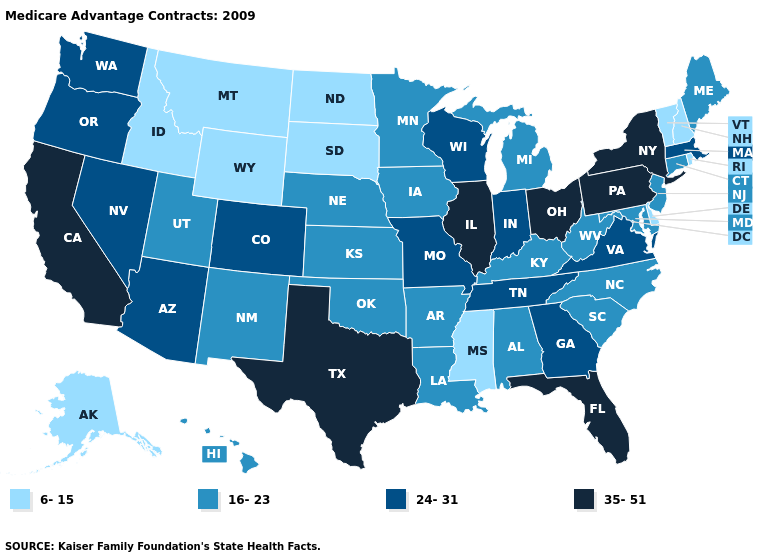What is the value of Illinois?
Write a very short answer. 35-51. Does Georgia have a higher value than West Virginia?
Keep it brief. Yes. Name the states that have a value in the range 16-23?
Quick response, please. Alabama, Arkansas, Connecticut, Hawaii, Iowa, Kansas, Kentucky, Louisiana, Maryland, Maine, Michigan, Minnesota, North Carolina, Nebraska, New Jersey, New Mexico, Oklahoma, South Carolina, Utah, West Virginia. What is the value of Florida?
Write a very short answer. 35-51. Name the states that have a value in the range 24-31?
Be succinct. Arizona, Colorado, Georgia, Indiana, Massachusetts, Missouri, Nevada, Oregon, Tennessee, Virginia, Washington, Wisconsin. Does Idaho have the highest value in the West?
Short answer required. No. What is the value of Wyoming?
Concise answer only. 6-15. What is the highest value in the South ?
Write a very short answer. 35-51. Does Tennessee have the same value as Illinois?
Quick response, please. No. Among the states that border New Jersey , does Pennsylvania have the highest value?
Give a very brief answer. Yes. Among the states that border Louisiana , which have the lowest value?
Write a very short answer. Mississippi. Which states have the highest value in the USA?
Be succinct. California, Florida, Illinois, New York, Ohio, Pennsylvania, Texas. What is the value of West Virginia?
Write a very short answer. 16-23. Name the states that have a value in the range 6-15?
Be succinct. Alaska, Delaware, Idaho, Mississippi, Montana, North Dakota, New Hampshire, Rhode Island, South Dakota, Vermont, Wyoming. Among the states that border Utah , does Wyoming have the highest value?
Short answer required. No. 